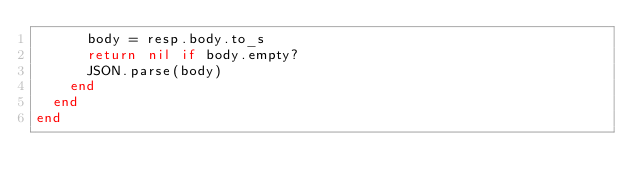Convert code to text. <code><loc_0><loc_0><loc_500><loc_500><_Ruby_>      body = resp.body.to_s
      return nil if body.empty?
      JSON.parse(body)
    end
  end
end
</code> 